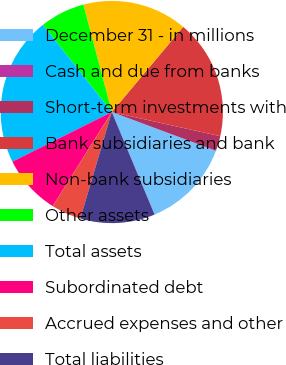Convert chart. <chart><loc_0><loc_0><loc_500><loc_500><pie_chart><fcel>December 31 - in millions<fcel>Cash and due from banks<fcel>Short-term investments with<fcel>Bank subsidiaries and bank<fcel>Non-bank subsidiaries<fcel>Other assets<fcel>Total assets<fcel>Subordinated debt<fcel>Accrued expenses and other<fcel>Total liabilities<nl><fcel>13.04%<fcel>0.0%<fcel>2.18%<fcel>17.39%<fcel>15.22%<fcel>6.52%<fcel>21.73%<fcel>8.7%<fcel>4.35%<fcel>10.87%<nl></chart> 